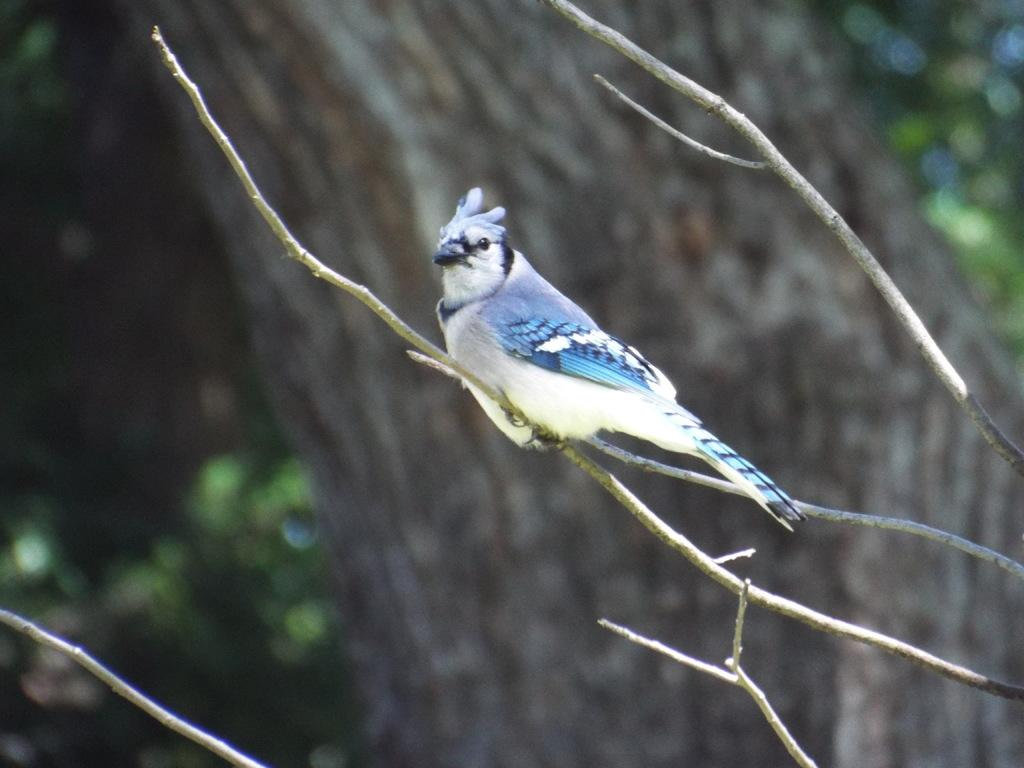What type of animal can be seen in the image? There is a bird in the image. Where is the bird located? The bird is sitting on a branch of a tree. Can you describe the background of the image? The background of the image is blurred. What type of needle is the bird using to sew in the image? There is no needle present in the image, and the bird is not sewing. 